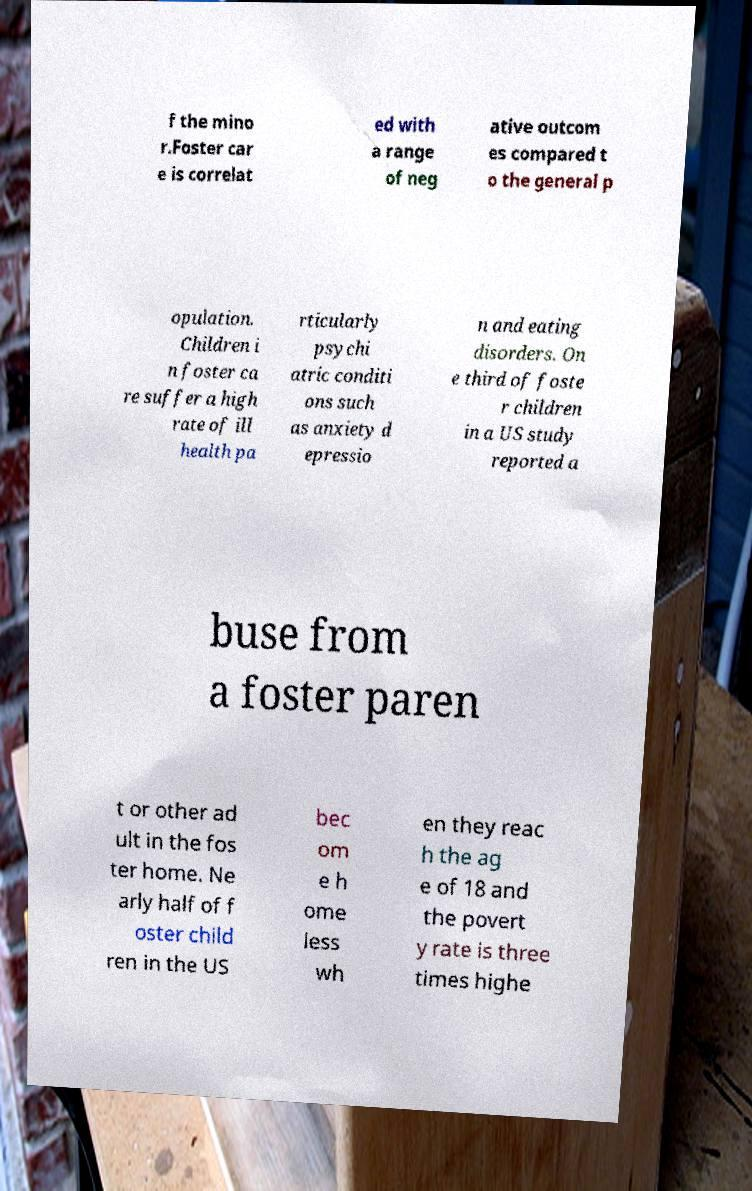For documentation purposes, I need the text within this image transcribed. Could you provide that? f the mino r.Foster car e is correlat ed with a range of neg ative outcom es compared t o the general p opulation. Children i n foster ca re suffer a high rate of ill health pa rticularly psychi atric conditi ons such as anxiety d epressio n and eating disorders. On e third of foste r children in a US study reported a buse from a foster paren t or other ad ult in the fos ter home. Ne arly half of f oster child ren in the US bec om e h ome less wh en they reac h the ag e of 18 and the povert y rate is three times highe 